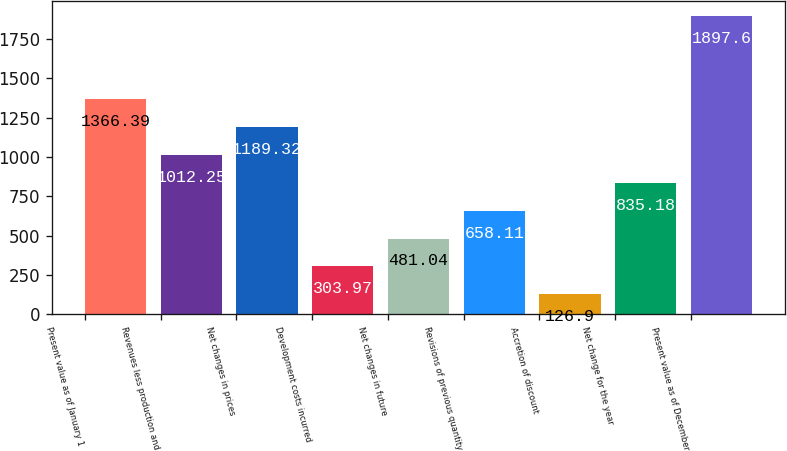Convert chart to OTSL. <chart><loc_0><loc_0><loc_500><loc_500><bar_chart><fcel>Present value as of January 1<fcel>Revenues less production and<fcel>Net changes in prices<fcel>Development costs incurred<fcel>Net changes in future<fcel>Revisions of previous quantity<fcel>Accretion of discount<fcel>Net change for the year<fcel>Present value as of December<nl><fcel>1366.39<fcel>1012.25<fcel>1189.32<fcel>303.97<fcel>481.04<fcel>658.11<fcel>126.9<fcel>835.18<fcel>1897.6<nl></chart> 